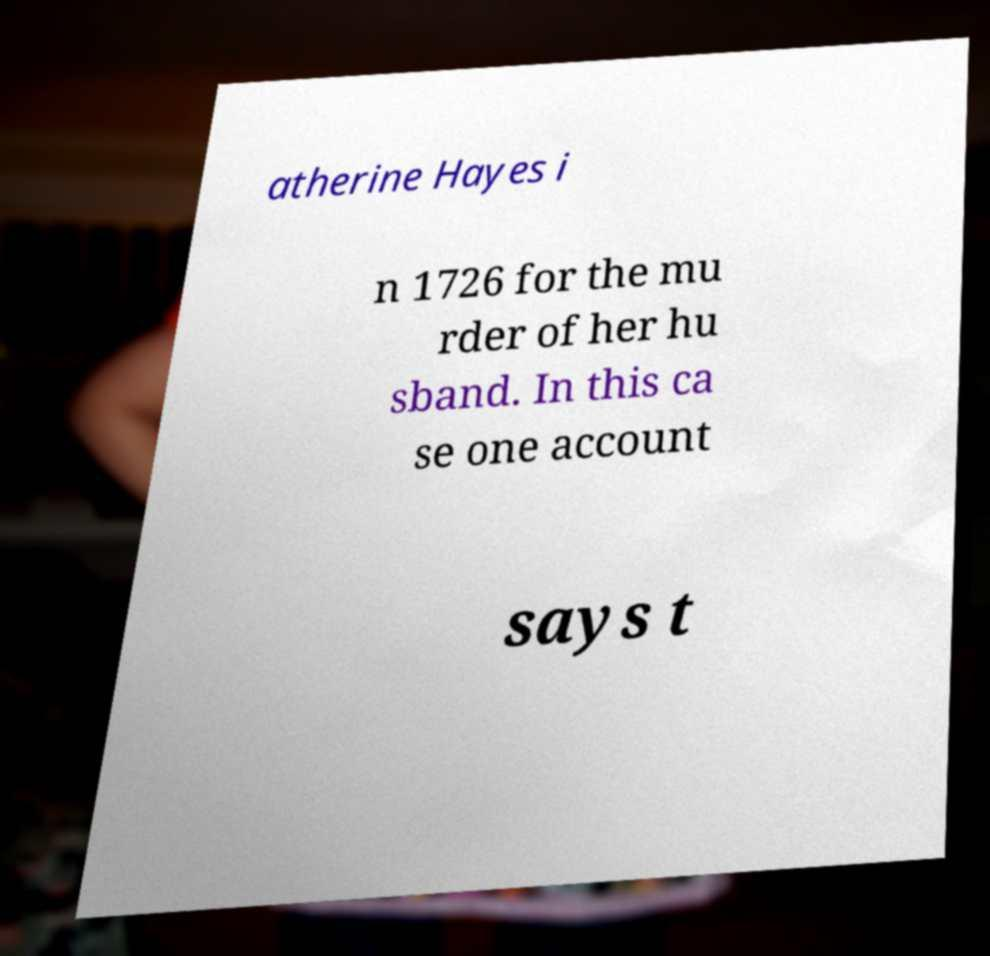For documentation purposes, I need the text within this image transcribed. Could you provide that? atherine Hayes i n 1726 for the mu rder of her hu sband. In this ca se one account says t 